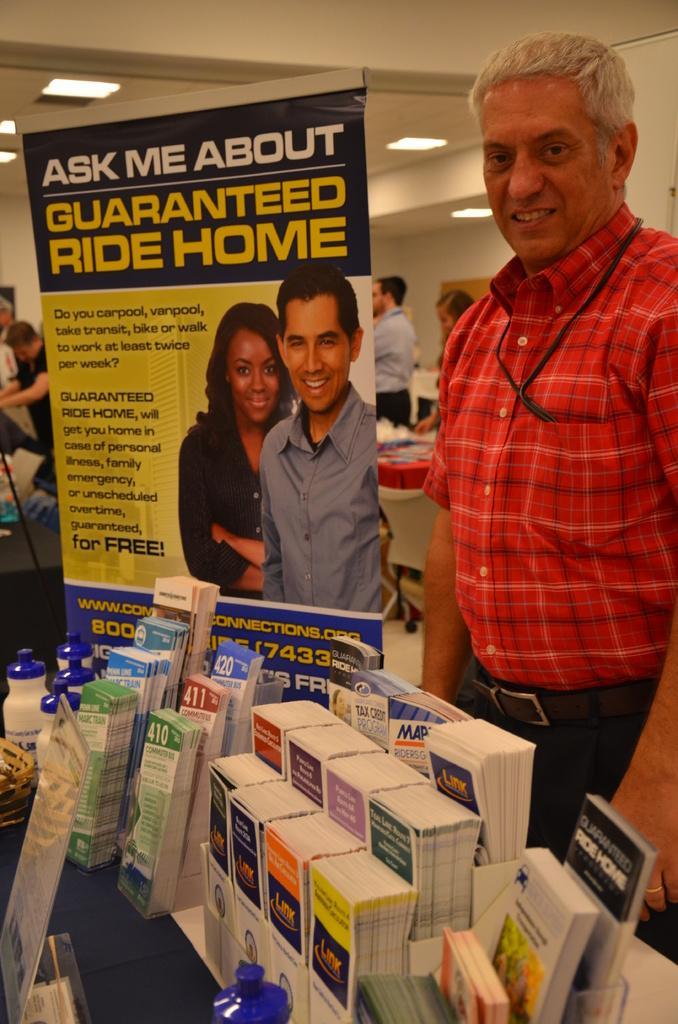How would you summarize this image in a sentence or two? This picture describes about group of people, in front of them we can see few books, bottles and other things on the tables, in the middle of the image we can see a hoarding, and also we can find few lights. 